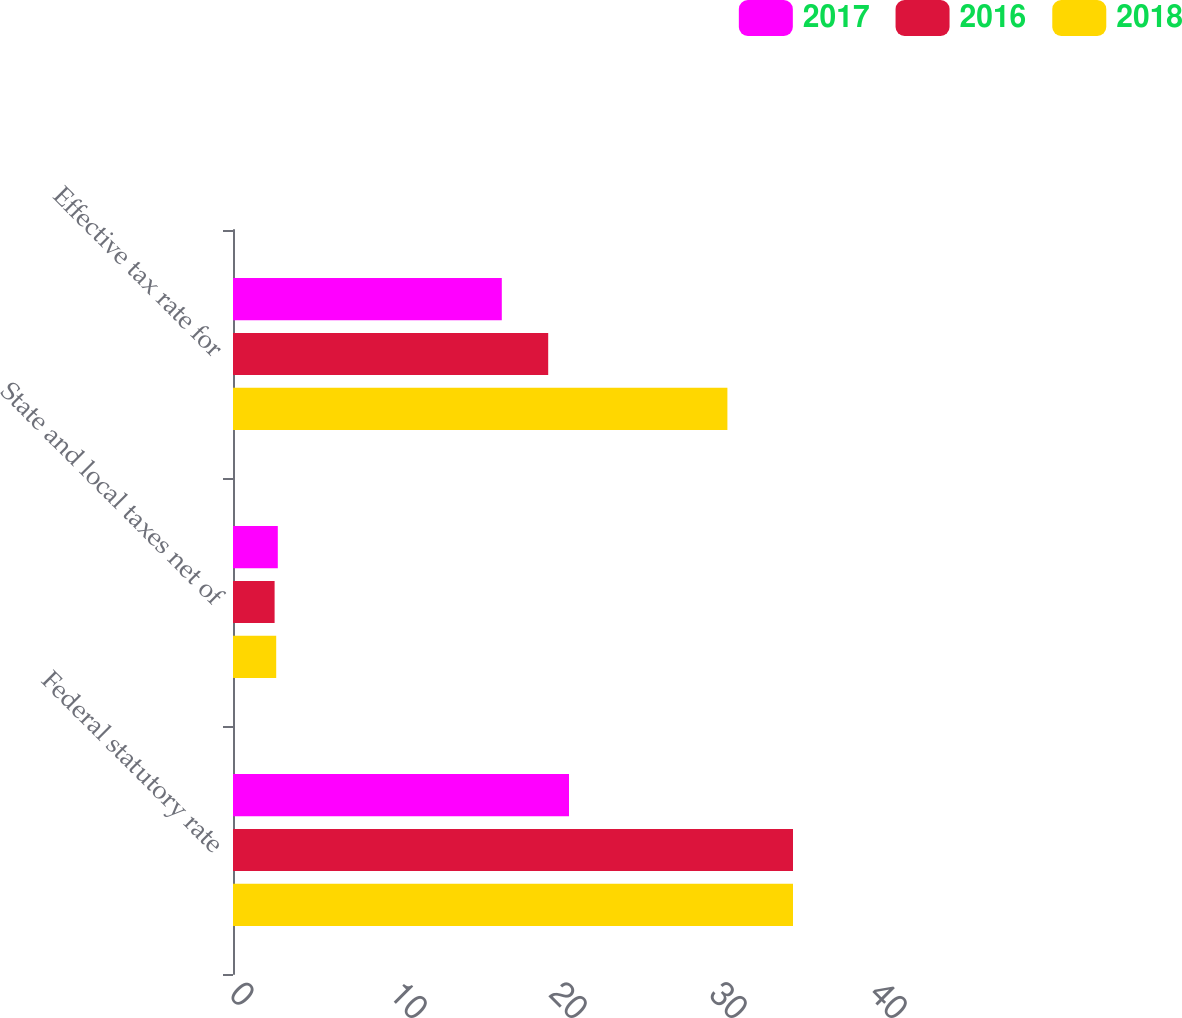Convert chart. <chart><loc_0><loc_0><loc_500><loc_500><stacked_bar_chart><ecel><fcel>Federal statutory rate<fcel>State and local taxes net of<fcel>Effective tax rate for<nl><fcel>2017<fcel>21<fcel>2.8<fcel>16.8<nl><fcel>2016<fcel>35<fcel>2.6<fcel>19.7<nl><fcel>2018<fcel>35<fcel>2.7<fcel>30.9<nl></chart> 